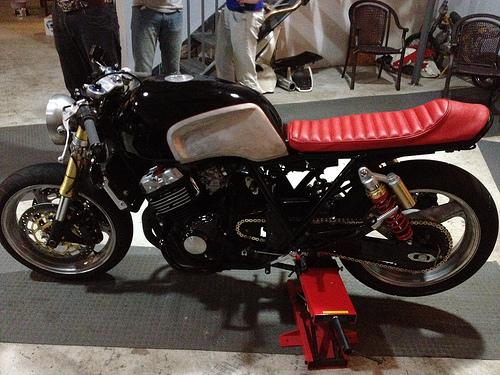Briefly explain what is happening in the lower part of the image, specifically focusing on the ground beneath the motorcycle. The motorcycle is parked on a grey pavement, with a black shadow beneath it and small parts of grey pavement visible around it. Describe the clothing items and their colors that can be seen in the picture. There are a pair of white pants, a pair of blue jeans, and a pair of beige pants visible in the image. In the context of this image, describe the interaction between the motorcycle and the red ramp. The red motorcycle ramp is positioned next to the motorcycle, ready to be used as a platform for the motorcycle to perform stunts or for maintenance purposes. How many chairs can you see in this image, and what material are they made of? There are four chairs in the image, made of steel and featuring a black and brown color scheme. Identify the main object in the image and provide a brief description of its color and appearance. The main object in the image is a black and red motorcycle with a vintage style, parked on grey pavement. What type of motorcycle is displayed in the image, and what are some notable features about it? The image displays a vintage red and black motorcycle with features such as a red leather seat, front and rear tires, a headlamp, and a chain. Using the given information, perform an object counting task by specifying the number of motorcycles, chairs, and clothing items in the image. The image contains one motorcycle, four chairs, and three clothing items (two pairs of pants and one pair of jeans). Please list the different parts of the motorcycle that can be seen in the image. The visible motorcycle parts include the headlight, front and rear tires, seat, a part of the engine, suspension, and chain. What emotions or feelings can be associated with this image, keeping in mind the motorcycle and its surroundings? The image evokes feelings of nostalgia, freedom, and adventure due to the vintage style of the motorcycle and its parked position, waiting for someone to ride it. How many parts of the motorcycle can be considered as characteristic or attention-catching in the image? There are around ten attention-catching parts of the motorcycle, including the red leather seat, front and rear tires, headlamp, chain, and the suspension system. Can you find the person wearing a red shirt in the image? The image only mentions people wearing various colored pants or jeans, not any shirts or specifically a red shirt. Where is the yellow helmet on the motorcycle? No yellow helmet is mentioned in any of the captions, so there is no such item in the image. Locate the orange bicycle in the background. All mentioned bikes are motorcycles, not bicycles, and none are specified as being orange. Can you spot the green motorcycle in the image? There is no green motorcycle in any of the mentioned captions. All motorcycles mentioned are either red, black, or not specified in color. Is there a large purple rug on the floor next to the motorcycle? The floor only has a grey floor mat mentioned in the captions, no purple rugs or other floor coverings are specified. Is there a round table with four legs in the picture? There are only chairs with four legs mentioned in the captions, no tables are specified. 